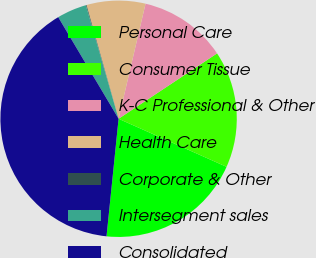Convert chart to OTSL. <chart><loc_0><loc_0><loc_500><loc_500><pie_chart><fcel>Personal Care<fcel>Consumer Tissue<fcel>K-C Professional & Other<fcel>Health Care<fcel>Corporate & Other<fcel>Intersegment sales<fcel>Consolidated<nl><fcel>19.96%<fcel>15.99%<fcel>12.01%<fcel>8.04%<fcel>0.09%<fcel>4.06%<fcel>39.84%<nl></chart> 